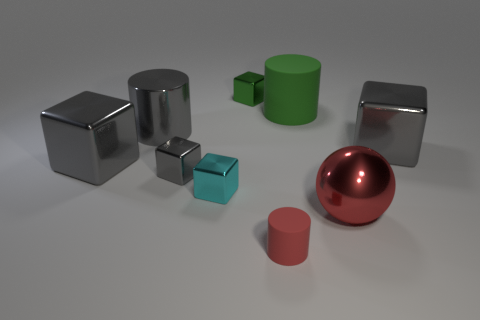How many other objects are there of the same color as the sphere?
Offer a terse response. 1. What number of balls are metallic things or tiny green objects?
Your answer should be very brief. 1. There is a large metallic cube that is to the right of the tiny metallic object behind the green rubber object; what color is it?
Your response must be concise. Gray. What is the shape of the large red shiny object?
Make the answer very short. Sphere. There is a rubber thing in front of the cyan object; is it the same size as the small gray metal cube?
Offer a very short reply. Yes. Are there any large gray things made of the same material as the large green cylinder?
Your answer should be compact. No. What number of things are either big objects behind the large red metallic thing or blocks?
Your answer should be compact. 7. Is there a green metal thing?
Your answer should be compact. Yes. There is a thing that is both to the right of the small green shiny object and to the left of the big matte cylinder; what is its shape?
Provide a succinct answer. Cylinder. What size is the rubber thing behind the tiny cyan object?
Your answer should be very brief. Large. 